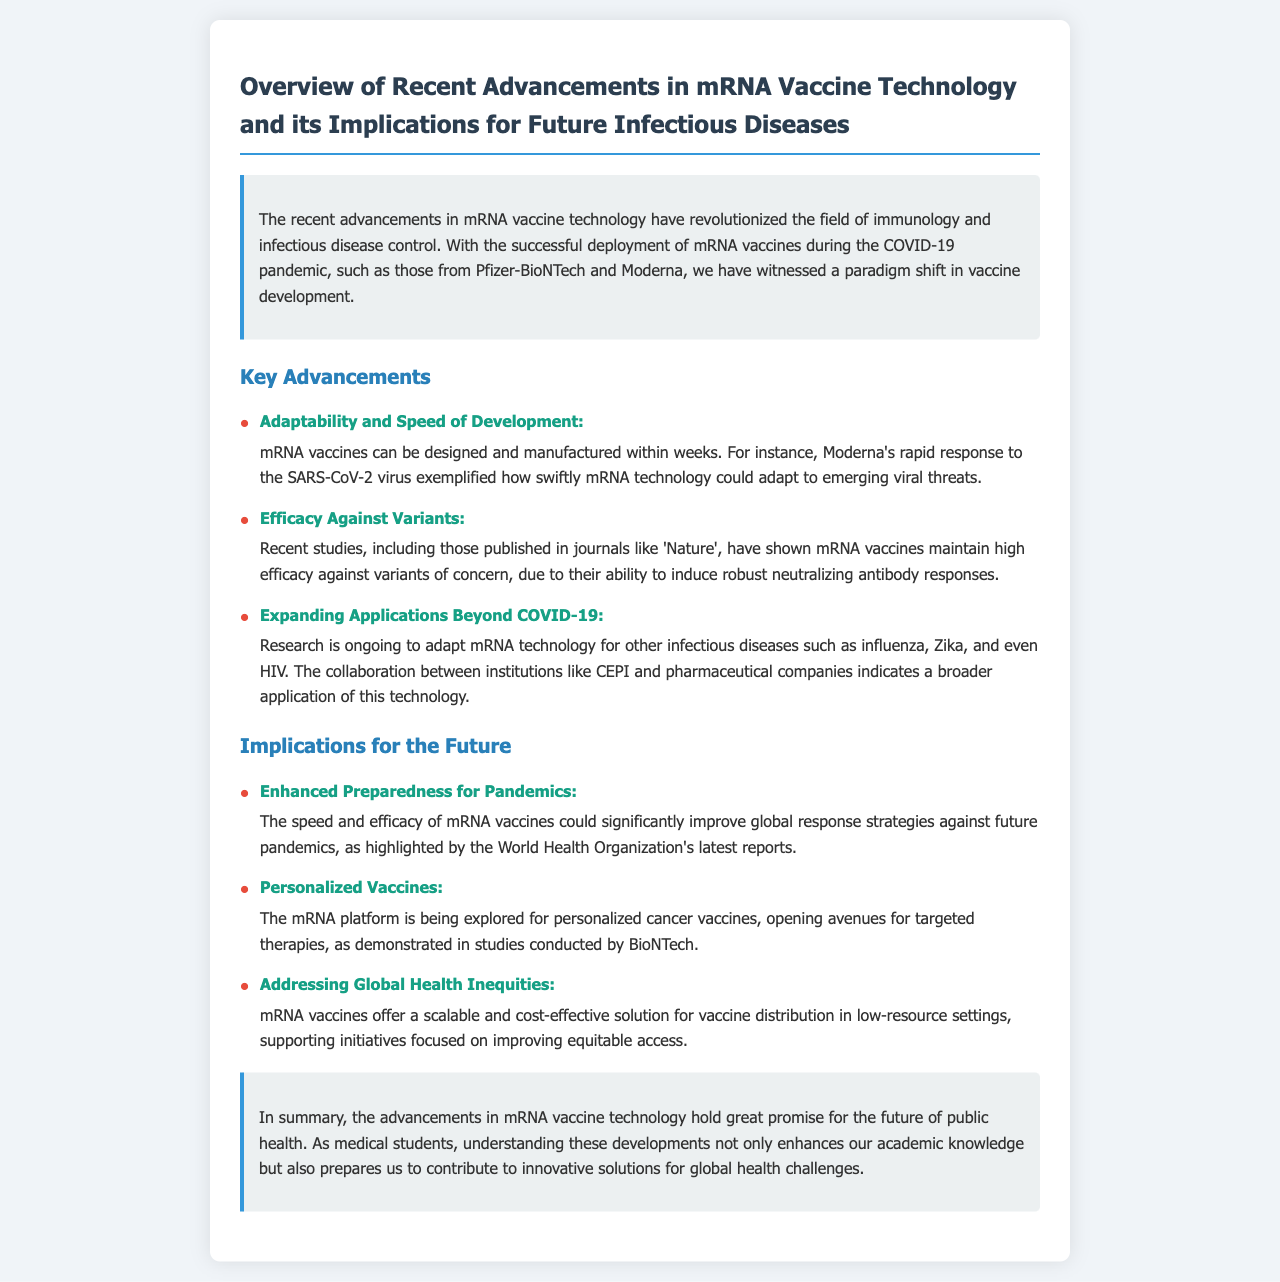What is the title of the document? The title of the document is presented in the header, summarizing its focus on recent advancements in mRNA vaccine technology.
Answer: Overview of Recent Advancements in mRNA Vaccine Technology and its Implications for Future Infectious Diseases What is an example of an mRNA vaccine mentioned? The document provides examples of mRNA vaccines deployed during the COVID-19 pandemic, specifically naming two manufacturers.
Answer: Pfizer-BioNTech and Moderna How quickly can mRNA vaccines be developed? The document specifies the speed at which mRNA vaccines can be designed and manufactured, emphasizing their rapid development for emerging viral threats.
Answer: Within weeks Which variant's efficacy is highlighted in recent studies? The document discusses mRNA vaccines maintaining high efficacy against specific variants of concern as noted in scholarly publications.
Answer: Variants of concern What is one implication for future pandemics? The implication section outlines how advancements in mRNA vaccine technology can enhance global health strategies against pandemics.
Answer: Enhanced Preparedness for Pandemics What type of diseases is ongoing research targeting with mRNA technology besides COVID-19? The document mentions several infectious diseases that researchers are focusing on adapting mRNA technology for, illustrating the potential broader applications.
Answer: Influenza, Zika, and HIV Which organization’s reports highlight the benefits of mRNA vaccines for global response strategies? The document refers to specific authoritative publications that discuss the significant impact of mRNA vaccines on public health preparedness.
Answer: World Health Organization What does the mRNA platform offer for cancer treatment? The document discusses research exploring personalized therapies in oncology, utilizing mRNA technology for specific applications.
Answer: Personalized cancer vaccines 